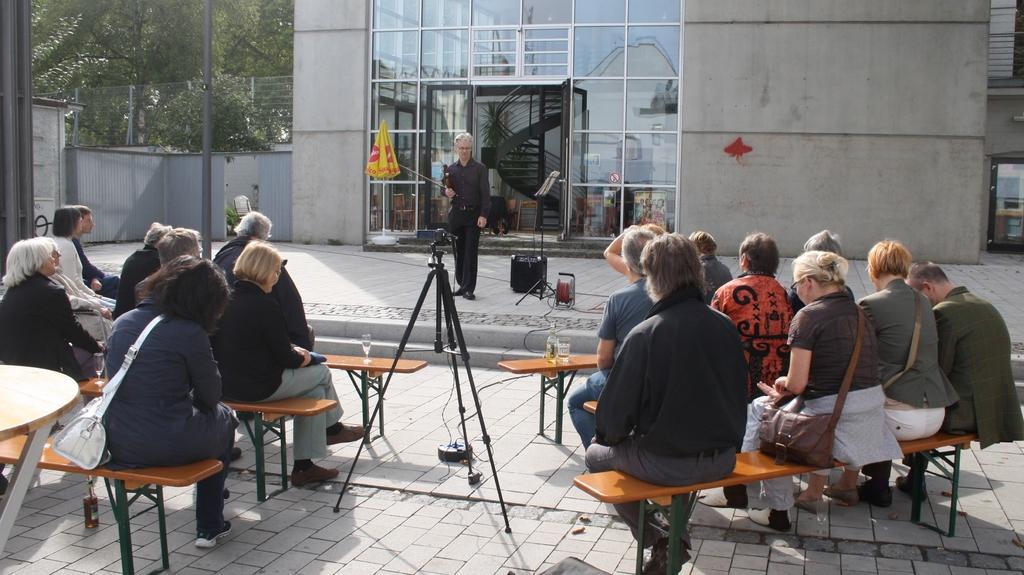In one or two sentences, can you explain what this image depicts? This picture shows people seated on the benches and we see few glasses and a bottle and we see a camera stand and a camera to it and we see a person standing and we see building and few trees 